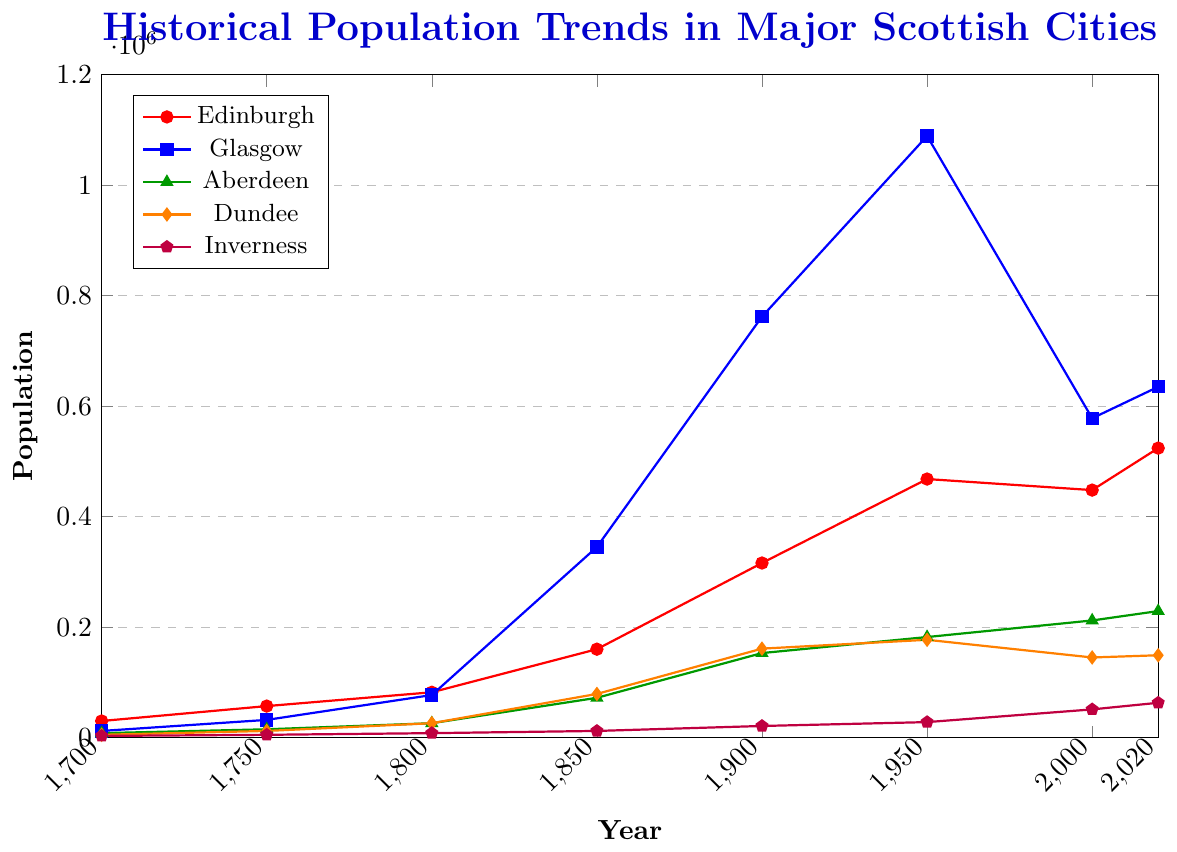Which city had the highest population in 1950? Look at the population values for 1950 for each city and identify the highest number.
Answer: Glasgow What is the difference in population between Edinburgh and Glasgow in 2020? Look at the population values for Edinburgh (524,000) and Glasgow (635,000) in 2020. Subtract the population of Edinburgh from Glasgow. 635,000 - 524,000 = 111,000
Answer: 111,000 How many cities had a population greater than 200,000 in 2020? Check the population values for all cities in 2020 and count how many exceed 200,000.
Answer: 3 Which city has shown the most significant population increase from 1700 to 2020? Calculate the population increase for each city from 1700 to 2020 by subtracting the population in 1700 from the population in 2020. Identify the largest increase. Glasgow: 635,000 - 12,000 = 623,000
Answer: Glasgow What was the average population of Aberdeen from 1700 to 2020? Sum the populations of Aberdeen for all given years: 8,000 + 15,000 + 26,000 + 72,000 + 153,000 + 182,000 + 212,000 + 229,000 = 897,000. Divide by the number of data points (8): 897,000 / 8 = 112,125
Answer: 112,125 In which period did Dundee experience the highest population growth? Look at the population values for Dundee and find the period with the highest increase. From 1800 to 1850: 79,000 - 26,000 = 53,000
Answer: 1800 to 1850 Which two cities had nearly equal populations in 1800? Compare the population values of all cities in 1800 and find any that are very close in value. Aberdeen (26,000) and Dundee (26,000) had the same population.
Answer: Aberdeen and Dundee What is the combined population of Inverness and Dundee in 2020? Add the population values of Inverness (63,000) and Dundee (149,000) in 2020. 63,000 + 149,000 = 212,000
Answer: 212,000 Which city had the smallest population in 1750? Look at the population values for 1750 for each city and identify the smallest number.
Answer: Inverness 